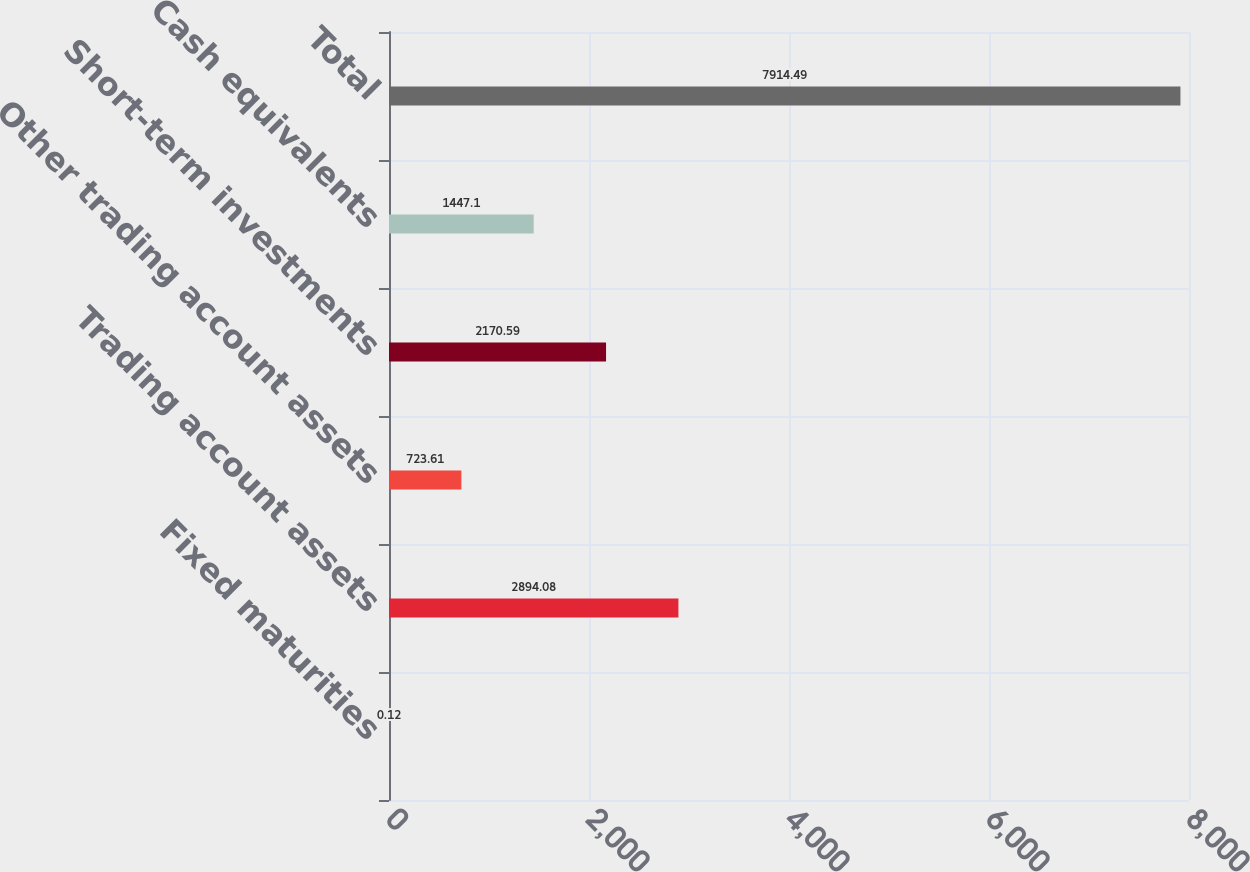Convert chart to OTSL. <chart><loc_0><loc_0><loc_500><loc_500><bar_chart><fcel>Fixed maturities<fcel>Trading account assets<fcel>Other trading account assets<fcel>Short-term investments<fcel>Cash equivalents<fcel>Total<nl><fcel>0.12<fcel>2894.08<fcel>723.61<fcel>2170.59<fcel>1447.1<fcel>7914.49<nl></chart> 